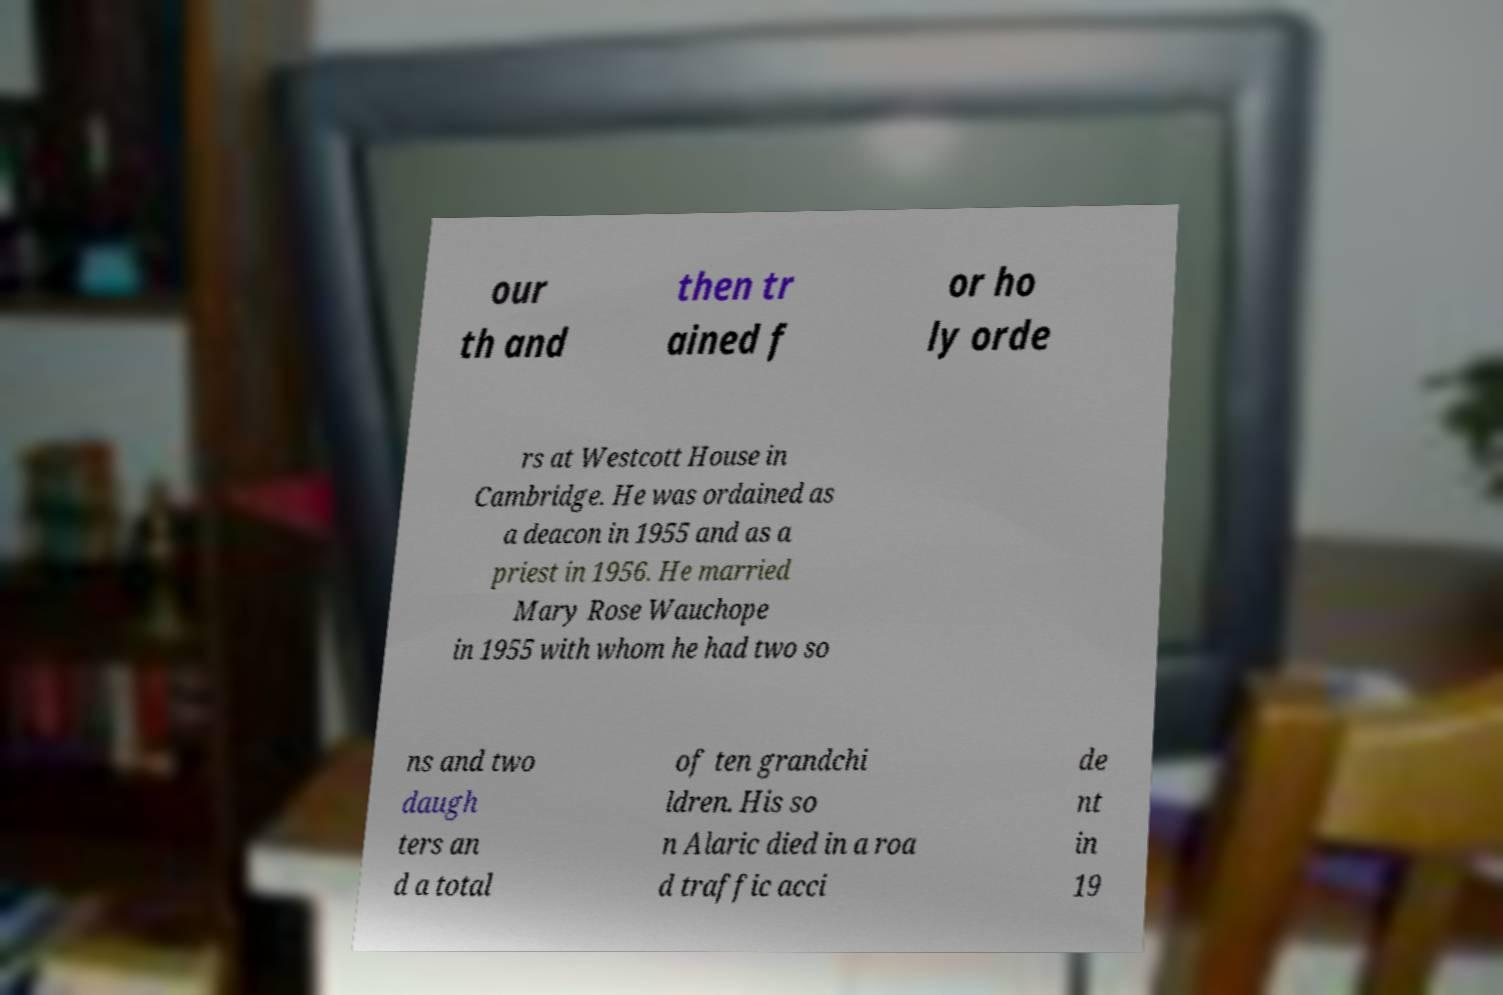I need the written content from this picture converted into text. Can you do that? our th and then tr ained f or ho ly orde rs at Westcott House in Cambridge. He was ordained as a deacon in 1955 and as a priest in 1956. He married Mary Rose Wauchope in 1955 with whom he had two so ns and two daugh ters an d a total of ten grandchi ldren. His so n Alaric died in a roa d traffic acci de nt in 19 